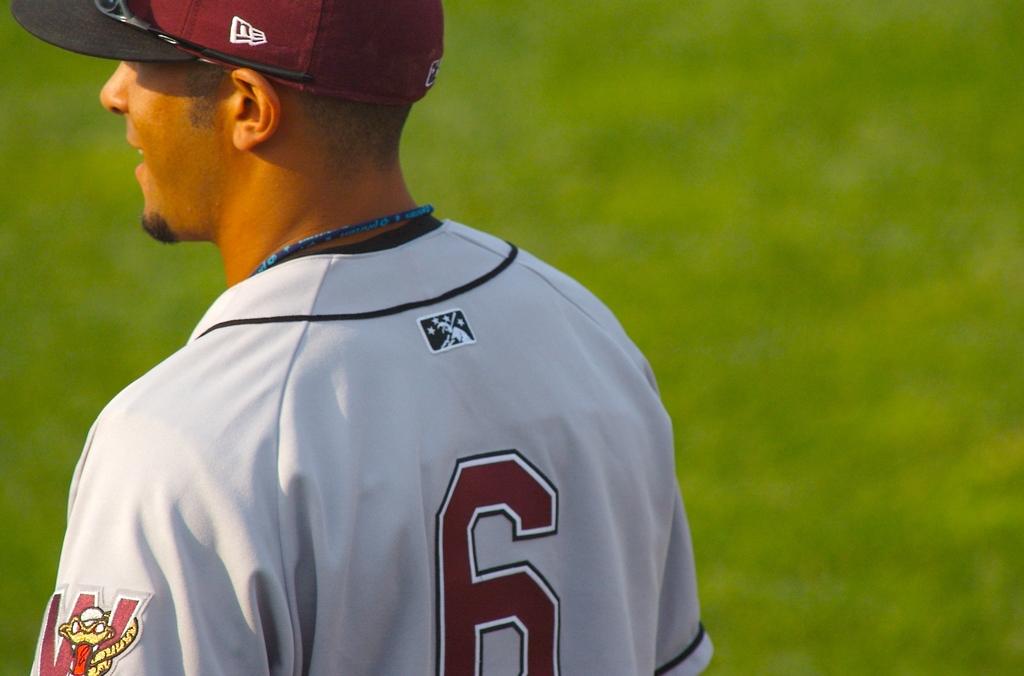What number is on the jersey?
Provide a short and direct response. 6. 